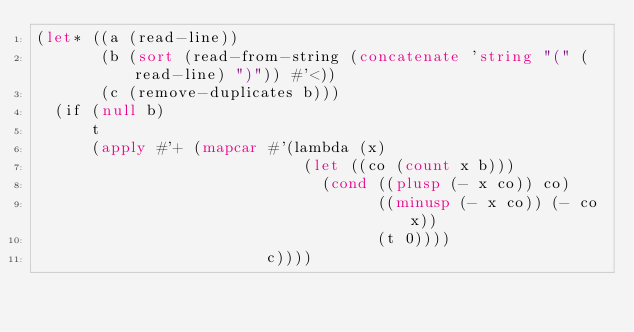<code> <loc_0><loc_0><loc_500><loc_500><_Lisp_>(let* ((a (read-line))
       (b (sort (read-from-string (concatenate 'string "(" (read-line) ")")) #'<))
       (c (remove-duplicates b)))
  (if (null b)
      t
      (apply #'+ (mapcar #'(lambda (x)
                             (let ((co (count x b)))
                               (cond ((plusp (- x co)) co)
                                     ((minusp (- x co)) (- co x))
                                     (t 0))))
                         c))))
</code> 